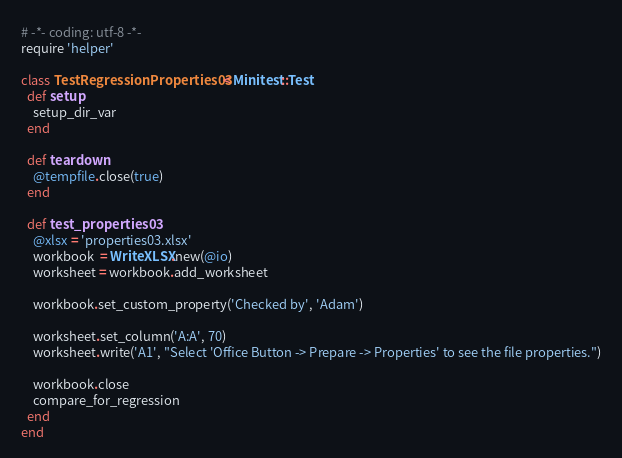Convert code to text. <code><loc_0><loc_0><loc_500><loc_500><_Ruby_># -*- coding: utf-8 -*-
require 'helper'

class TestRegressionProperties03 < Minitest::Test
  def setup
    setup_dir_var
  end

  def teardown
    @tempfile.close(true)
  end

  def test_properties03
    @xlsx = 'properties03.xlsx'
    workbook  = WriteXLSX.new(@io)
    worksheet = workbook.add_worksheet

    workbook.set_custom_property('Checked by', 'Adam')

    worksheet.set_column('A:A', 70)
    worksheet.write('A1', "Select 'Office Button -> Prepare -> Properties' to see the file properties.")

    workbook.close
    compare_for_regression
  end
end
</code> 